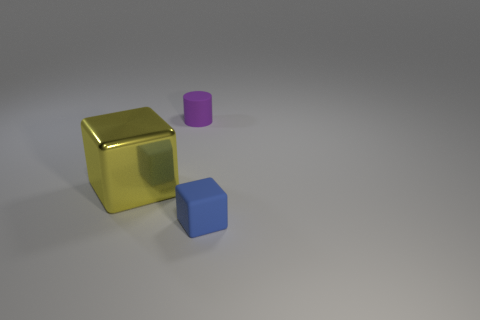Add 2 blue matte objects. How many objects exist? 5 Subtract all cylinders. How many objects are left? 2 Add 2 small blocks. How many small blocks are left? 3 Add 1 tiny matte cylinders. How many tiny matte cylinders exist? 2 Subtract 1 yellow blocks. How many objects are left? 2 Subtract all tiny purple rubber cylinders. Subtract all cylinders. How many objects are left? 1 